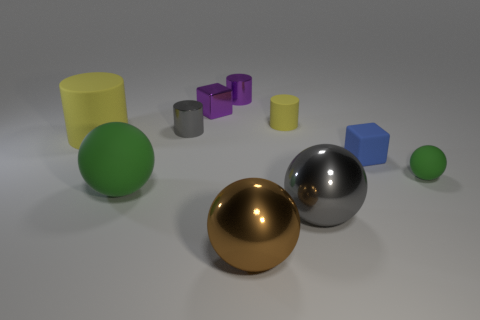Subtract all big yellow cylinders. How many cylinders are left? 3 Subtract 3 cylinders. How many cylinders are left? 1 Subtract all gray cylinders. How many cylinders are left? 3 Subtract all cubes. How many objects are left? 8 Subtract all red cylinders. Subtract all green spheres. How many cylinders are left? 4 Subtract all brown spheres. How many purple cylinders are left? 1 Subtract all large brown metal balls. Subtract all yellow cylinders. How many objects are left? 7 Add 5 blue things. How many blue things are left? 6 Add 1 large balls. How many large balls exist? 4 Subtract 1 brown spheres. How many objects are left? 9 